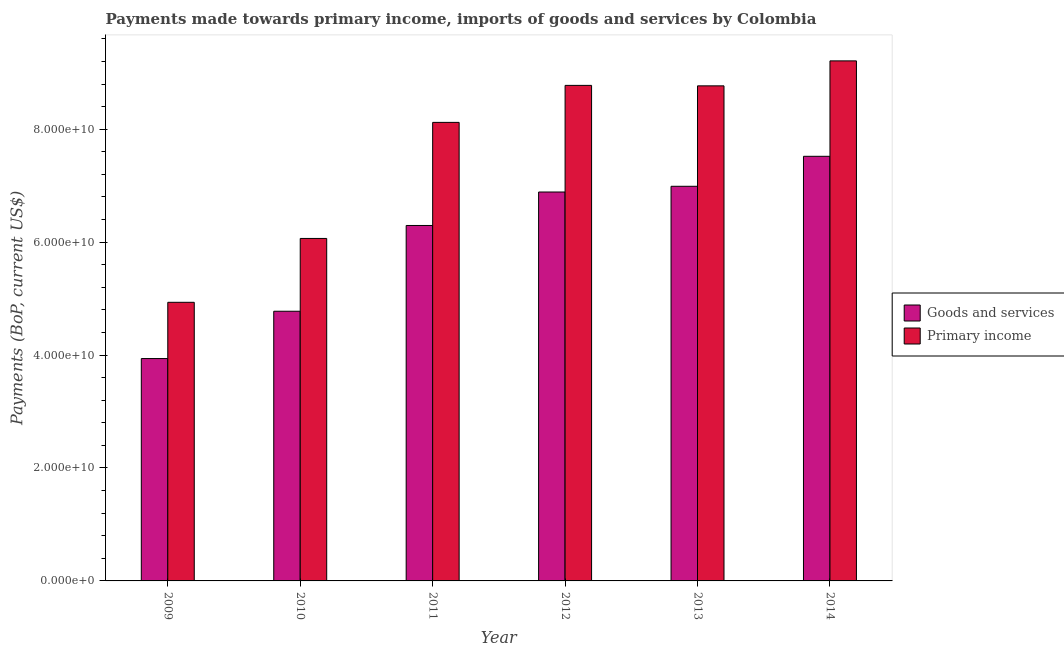How many different coloured bars are there?
Ensure brevity in your answer.  2. Are the number of bars per tick equal to the number of legend labels?
Your response must be concise. Yes. How many bars are there on the 6th tick from the left?
Your answer should be compact. 2. How many bars are there on the 3rd tick from the right?
Your response must be concise. 2. What is the label of the 4th group of bars from the left?
Your answer should be compact. 2012. What is the payments made towards goods and services in 2009?
Offer a very short reply. 3.94e+1. Across all years, what is the maximum payments made towards goods and services?
Give a very brief answer. 7.52e+1. Across all years, what is the minimum payments made towards goods and services?
Provide a short and direct response. 3.94e+1. In which year was the payments made towards goods and services maximum?
Offer a very short reply. 2014. What is the total payments made towards primary income in the graph?
Make the answer very short. 4.59e+11. What is the difference between the payments made towards primary income in 2009 and that in 2013?
Make the answer very short. -3.83e+1. What is the difference between the payments made towards goods and services in 2012 and the payments made towards primary income in 2010?
Make the answer very short. 2.11e+1. What is the average payments made towards goods and services per year?
Provide a short and direct response. 6.07e+1. In the year 2009, what is the difference between the payments made towards goods and services and payments made towards primary income?
Your answer should be very brief. 0. In how many years, is the payments made towards goods and services greater than 12000000000 US$?
Keep it short and to the point. 6. What is the ratio of the payments made towards primary income in 2010 to that in 2013?
Provide a succinct answer. 0.69. Is the payments made towards primary income in 2012 less than that in 2013?
Your answer should be very brief. No. Is the difference between the payments made towards goods and services in 2012 and 2013 greater than the difference between the payments made towards primary income in 2012 and 2013?
Your response must be concise. No. What is the difference between the highest and the second highest payments made towards goods and services?
Your response must be concise. 5.31e+09. What is the difference between the highest and the lowest payments made towards goods and services?
Make the answer very short. 3.58e+1. Is the sum of the payments made towards goods and services in 2009 and 2010 greater than the maximum payments made towards primary income across all years?
Provide a short and direct response. Yes. What does the 1st bar from the left in 2013 represents?
Offer a terse response. Goods and services. What does the 2nd bar from the right in 2010 represents?
Your answer should be very brief. Goods and services. How are the legend labels stacked?
Give a very brief answer. Vertical. What is the title of the graph?
Your answer should be compact. Payments made towards primary income, imports of goods and services by Colombia. What is the label or title of the Y-axis?
Provide a succinct answer. Payments (BoP, current US$). What is the Payments (BoP, current US$) of Goods and services in 2009?
Provide a short and direct response. 3.94e+1. What is the Payments (BoP, current US$) of Primary income in 2009?
Ensure brevity in your answer.  4.93e+1. What is the Payments (BoP, current US$) in Goods and services in 2010?
Your response must be concise. 4.78e+1. What is the Payments (BoP, current US$) in Primary income in 2010?
Your response must be concise. 6.07e+1. What is the Payments (BoP, current US$) in Goods and services in 2011?
Your answer should be very brief. 6.29e+1. What is the Payments (BoP, current US$) in Primary income in 2011?
Your answer should be compact. 8.12e+1. What is the Payments (BoP, current US$) of Goods and services in 2012?
Your answer should be compact. 6.89e+1. What is the Payments (BoP, current US$) of Primary income in 2012?
Provide a succinct answer. 8.78e+1. What is the Payments (BoP, current US$) of Goods and services in 2013?
Provide a succinct answer. 6.99e+1. What is the Payments (BoP, current US$) in Primary income in 2013?
Ensure brevity in your answer.  8.77e+1. What is the Payments (BoP, current US$) in Goods and services in 2014?
Your response must be concise. 7.52e+1. What is the Payments (BoP, current US$) in Primary income in 2014?
Provide a short and direct response. 9.21e+1. Across all years, what is the maximum Payments (BoP, current US$) of Goods and services?
Make the answer very short. 7.52e+1. Across all years, what is the maximum Payments (BoP, current US$) in Primary income?
Your answer should be compact. 9.21e+1. Across all years, what is the minimum Payments (BoP, current US$) of Goods and services?
Your answer should be compact. 3.94e+1. Across all years, what is the minimum Payments (BoP, current US$) in Primary income?
Keep it short and to the point. 4.93e+1. What is the total Payments (BoP, current US$) in Goods and services in the graph?
Give a very brief answer. 3.64e+11. What is the total Payments (BoP, current US$) of Primary income in the graph?
Offer a terse response. 4.59e+11. What is the difference between the Payments (BoP, current US$) of Goods and services in 2009 and that in 2010?
Your response must be concise. -8.38e+09. What is the difference between the Payments (BoP, current US$) in Primary income in 2009 and that in 2010?
Make the answer very short. -1.13e+1. What is the difference between the Payments (BoP, current US$) of Goods and services in 2009 and that in 2011?
Offer a very short reply. -2.36e+1. What is the difference between the Payments (BoP, current US$) of Primary income in 2009 and that in 2011?
Offer a terse response. -3.19e+1. What is the difference between the Payments (BoP, current US$) in Goods and services in 2009 and that in 2012?
Offer a very short reply. -2.95e+1. What is the difference between the Payments (BoP, current US$) of Primary income in 2009 and that in 2012?
Provide a succinct answer. -3.84e+1. What is the difference between the Payments (BoP, current US$) in Goods and services in 2009 and that in 2013?
Your answer should be very brief. -3.05e+1. What is the difference between the Payments (BoP, current US$) of Primary income in 2009 and that in 2013?
Provide a short and direct response. -3.83e+1. What is the difference between the Payments (BoP, current US$) of Goods and services in 2009 and that in 2014?
Offer a terse response. -3.58e+1. What is the difference between the Payments (BoP, current US$) in Primary income in 2009 and that in 2014?
Keep it short and to the point. -4.28e+1. What is the difference between the Payments (BoP, current US$) of Goods and services in 2010 and that in 2011?
Ensure brevity in your answer.  -1.52e+1. What is the difference between the Payments (BoP, current US$) of Primary income in 2010 and that in 2011?
Offer a terse response. -2.06e+1. What is the difference between the Payments (BoP, current US$) of Goods and services in 2010 and that in 2012?
Keep it short and to the point. -2.11e+1. What is the difference between the Payments (BoP, current US$) in Primary income in 2010 and that in 2012?
Offer a terse response. -2.71e+1. What is the difference between the Payments (BoP, current US$) of Goods and services in 2010 and that in 2013?
Your response must be concise. -2.21e+1. What is the difference between the Payments (BoP, current US$) of Primary income in 2010 and that in 2013?
Your answer should be compact. -2.70e+1. What is the difference between the Payments (BoP, current US$) in Goods and services in 2010 and that in 2014?
Your answer should be compact. -2.74e+1. What is the difference between the Payments (BoP, current US$) of Primary income in 2010 and that in 2014?
Provide a short and direct response. -3.14e+1. What is the difference between the Payments (BoP, current US$) in Goods and services in 2011 and that in 2012?
Keep it short and to the point. -5.93e+09. What is the difference between the Payments (BoP, current US$) of Primary income in 2011 and that in 2012?
Offer a terse response. -6.55e+09. What is the difference between the Payments (BoP, current US$) of Goods and services in 2011 and that in 2013?
Your response must be concise. -6.94e+09. What is the difference between the Payments (BoP, current US$) of Primary income in 2011 and that in 2013?
Make the answer very short. -6.47e+09. What is the difference between the Payments (BoP, current US$) in Goods and services in 2011 and that in 2014?
Your response must be concise. -1.23e+1. What is the difference between the Payments (BoP, current US$) in Primary income in 2011 and that in 2014?
Your answer should be compact. -1.09e+1. What is the difference between the Payments (BoP, current US$) in Goods and services in 2012 and that in 2013?
Keep it short and to the point. -1.01e+09. What is the difference between the Payments (BoP, current US$) in Primary income in 2012 and that in 2013?
Keep it short and to the point. 8.21e+07. What is the difference between the Payments (BoP, current US$) of Goods and services in 2012 and that in 2014?
Offer a terse response. -6.32e+09. What is the difference between the Payments (BoP, current US$) in Primary income in 2012 and that in 2014?
Offer a very short reply. -4.34e+09. What is the difference between the Payments (BoP, current US$) of Goods and services in 2013 and that in 2014?
Give a very brief answer. -5.31e+09. What is the difference between the Payments (BoP, current US$) in Primary income in 2013 and that in 2014?
Offer a terse response. -4.42e+09. What is the difference between the Payments (BoP, current US$) of Goods and services in 2009 and the Payments (BoP, current US$) of Primary income in 2010?
Keep it short and to the point. -2.13e+1. What is the difference between the Payments (BoP, current US$) in Goods and services in 2009 and the Payments (BoP, current US$) in Primary income in 2011?
Give a very brief answer. -4.18e+1. What is the difference between the Payments (BoP, current US$) of Goods and services in 2009 and the Payments (BoP, current US$) of Primary income in 2012?
Offer a very short reply. -4.84e+1. What is the difference between the Payments (BoP, current US$) in Goods and services in 2009 and the Payments (BoP, current US$) in Primary income in 2013?
Make the answer very short. -4.83e+1. What is the difference between the Payments (BoP, current US$) of Goods and services in 2009 and the Payments (BoP, current US$) of Primary income in 2014?
Provide a short and direct response. -5.27e+1. What is the difference between the Payments (BoP, current US$) in Goods and services in 2010 and the Payments (BoP, current US$) in Primary income in 2011?
Ensure brevity in your answer.  -3.34e+1. What is the difference between the Payments (BoP, current US$) of Goods and services in 2010 and the Payments (BoP, current US$) of Primary income in 2012?
Keep it short and to the point. -4.00e+1. What is the difference between the Payments (BoP, current US$) in Goods and services in 2010 and the Payments (BoP, current US$) in Primary income in 2013?
Give a very brief answer. -3.99e+1. What is the difference between the Payments (BoP, current US$) of Goods and services in 2010 and the Payments (BoP, current US$) of Primary income in 2014?
Provide a short and direct response. -4.43e+1. What is the difference between the Payments (BoP, current US$) in Goods and services in 2011 and the Payments (BoP, current US$) in Primary income in 2012?
Give a very brief answer. -2.48e+1. What is the difference between the Payments (BoP, current US$) in Goods and services in 2011 and the Payments (BoP, current US$) in Primary income in 2013?
Keep it short and to the point. -2.47e+1. What is the difference between the Payments (BoP, current US$) of Goods and services in 2011 and the Payments (BoP, current US$) of Primary income in 2014?
Make the answer very short. -2.92e+1. What is the difference between the Payments (BoP, current US$) of Goods and services in 2012 and the Payments (BoP, current US$) of Primary income in 2013?
Provide a succinct answer. -1.88e+1. What is the difference between the Payments (BoP, current US$) of Goods and services in 2012 and the Payments (BoP, current US$) of Primary income in 2014?
Make the answer very short. -2.32e+1. What is the difference between the Payments (BoP, current US$) of Goods and services in 2013 and the Payments (BoP, current US$) of Primary income in 2014?
Ensure brevity in your answer.  -2.22e+1. What is the average Payments (BoP, current US$) in Goods and services per year?
Your response must be concise. 6.07e+1. What is the average Payments (BoP, current US$) of Primary income per year?
Your response must be concise. 7.65e+1. In the year 2009, what is the difference between the Payments (BoP, current US$) in Goods and services and Payments (BoP, current US$) in Primary income?
Provide a succinct answer. -9.96e+09. In the year 2010, what is the difference between the Payments (BoP, current US$) in Goods and services and Payments (BoP, current US$) in Primary income?
Offer a very short reply. -1.29e+1. In the year 2011, what is the difference between the Payments (BoP, current US$) in Goods and services and Payments (BoP, current US$) in Primary income?
Your answer should be very brief. -1.83e+1. In the year 2012, what is the difference between the Payments (BoP, current US$) of Goods and services and Payments (BoP, current US$) of Primary income?
Provide a short and direct response. -1.89e+1. In the year 2013, what is the difference between the Payments (BoP, current US$) in Goods and services and Payments (BoP, current US$) in Primary income?
Give a very brief answer. -1.78e+1. In the year 2014, what is the difference between the Payments (BoP, current US$) of Goods and services and Payments (BoP, current US$) of Primary income?
Make the answer very short. -1.69e+1. What is the ratio of the Payments (BoP, current US$) in Goods and services in 2009 to that in 2010?
Ensure brevity in your answer.  0.82. What is the ratio of the Payments (BoP, current US$) in Primary income in 2009 to that in 2010?
Your answer should be compact. 0.81. What is the ratio of the Payments (BoP, current US$) of Goods and services in 2009 to that in 2011?
Offer a very short reply. 0.63. What is the ratio of the Payments (BoP, current US$) of Primary income in 2009 to that in 2011?
Offer a terse response. 0.61. What is the ratio of the Payments (BoP, current US$) of Goods and services in 2009 to that in 2012?
Make the answer very short. 0.57. What is the ratio of the Payments (BoP, current US$) of Primary income in 2009 to that in 2012?
Provide a succinct answer. 0.56. What is the ratio of the Payments (BoP, current US$) in Goods and services in 2009 to that in 2013?
Offer a terse response. 0.56. What is the ratio of the Payments (BoP, current US$) of Primary income in 2009 to that in 2013?
Provide a succinct answer. 0.56. What is the ratio of the Payments (BoP, current US$) of Goods and services in 2009 to that in 2014?
Give a very brief answer. 0.52. What is the ratio of the Payments (BoP, current US$) in Primary income in 2009 to that in 2014?
Provide a short and direct response. 0.54. What is the ratio of the Payments (BoP, current US$) of Goods and services in 2010 to that in 2011?
Offer a very short reply. 0.76. What is the ratio of the Payments (BoP, current US$) of Primary income in 2010 to that in 2011?
Your response must be concise. 0.75. What is the ratio of the Payments (BoP, current US$) of Goods and services in 2010 to that in 2012?
Give a very brief answer. 0.69. What is the ratio of the Payments (BoP, current US$) of Primary income in 2010 to that in 2012?
Give a very brief answer. 0.69. What is the ratio of the Payments (BoP, current US$) in Goods and services in 2010 to that in 2013?
Your answer should be compact. 0.68. What is the ratio of the Payments (BoP, current US$) of Primary income in 2010 to that in 2013?
Your answer should be very brief. 0.69. What is the ratio of the Payments (BoP, current US$) of Goods and services in 2010 to that in 2014?
Ensure brevity in your answer.  0.64. What is the ratio of the Payments (BoP, current US$) in Primary income in 2010 to that in 2014?
Provide a succinct answer. 0.66. What is the ratio of the Payments (BoP, current US$) of Goods and services in 2011 to that in 2012?
Offer a terse response. 0.91. What is the ratio of the Payments (BoP, current US$) in Primary income in 2011 to that in 2012?
Your answer should be compact. 0.93. What is the ratio of the Payments (BoP, current US$) of Goods and services in 2011 to that in 2013?
Keep it short and to the point. 0.9. What is the ratio of the Payments (BoP, current US$) in Primary income in 2011 to that in 2013?
Provide a short and direct response. 0.93. What is the ratio of the Payments (BoP, current US$) in Goods and services in 2011 to that in 2014?
Give a very brief answer. 0.84. What is the ratio of the Payments (BoP, current US$) of Primary income in 2011 to that in 2014?
Your answer should be compact. 0.88. What is the ratio of the Payments (BoP, current US$) of Goods and services in 2012 to that in 2013?
Your response must be concise. 0.99. What is the ratio of the Payments (BoP, current US$) of Primary income in 2012 to that in 2013?
Provide a succinct answer. 1. What is the ratio of the Payments (BoP, current US$) in Goods and services in 2012 to that in 2014?
Your response must be concise. 0.92. What is the ratio of the Payments (BoP, current US$) of Primary income in 2012 to that in 2014?
Offer a very short reply. 0.95. What is the ratio of the Payments (BoP, current US$) in Goods and services in 2013 to that in 2014?
Your response must be concise. 0.93. What is the difference between the highest and the second highest Payments (BoP, current US$) of Goods and services?
Your response must be concise. 5.31e+09. What is the difference between the highest and the second highest Payments (BoP, current US$) in Primary income?
Your response must be concise. 4.34e+09. What is the difference between the highest and the lowest Payments (BoP, current US$) of Goods and services?
Provide a succinct answer. 3.58e+1. What is the difference between the highest and the lowest Payments (BoP, current US$) of Primary income?
Ensure brevity in your answer.  4.28e+1. 